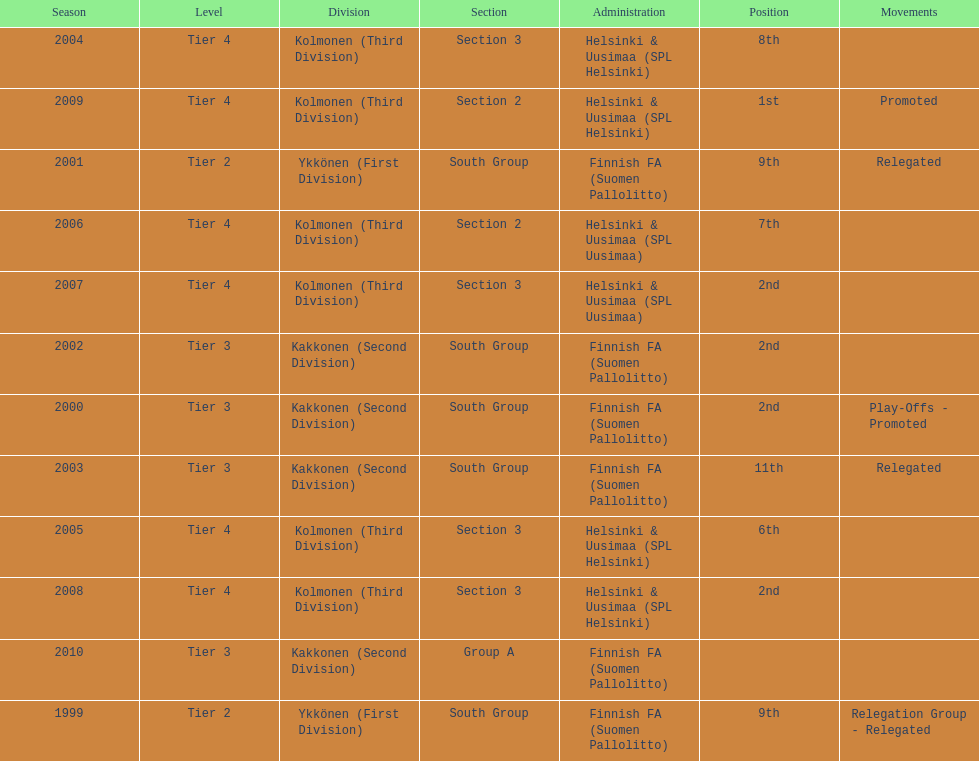How many consecutive times did they play in tier 4? 6. 